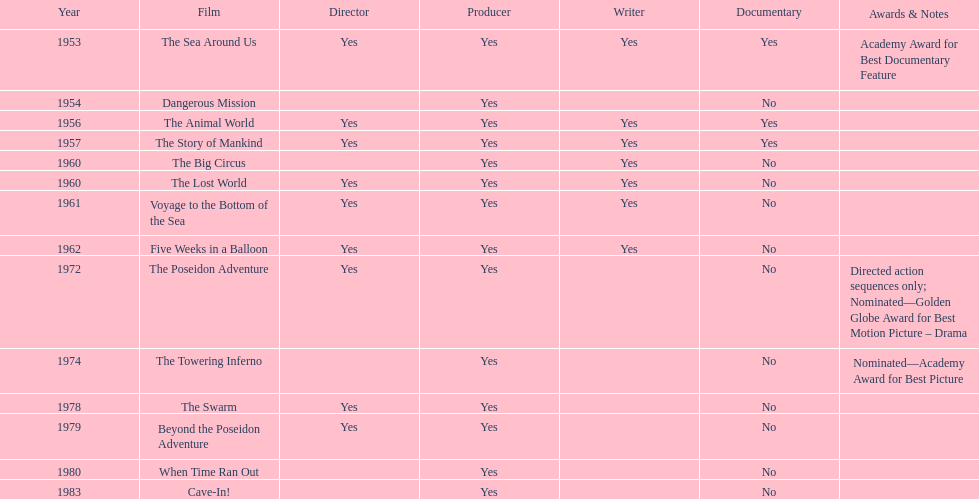How many films did irwin allen direct, produce and write? 6. 